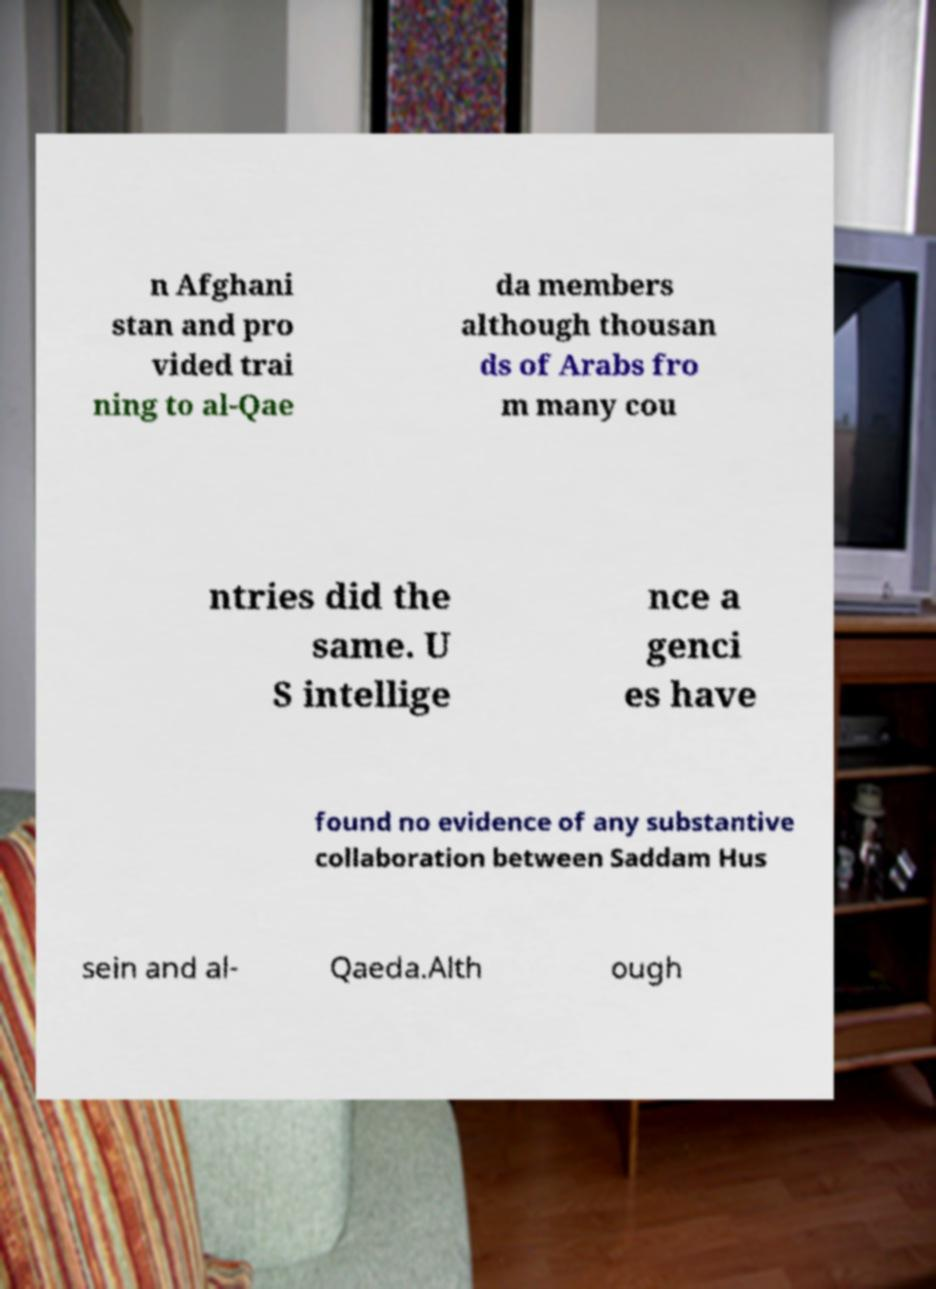I need the written content from this picture converted into text. Can you do that? n Afghani stan and pro vided trai ning to al-Qae da members although thousan ds of Arabs fro m many cou ntries did the same. U S intellige nce a genci es have found no evidence of any substantive collaboration between Saddam Hus sein and al- Qaeda.Alth ough 